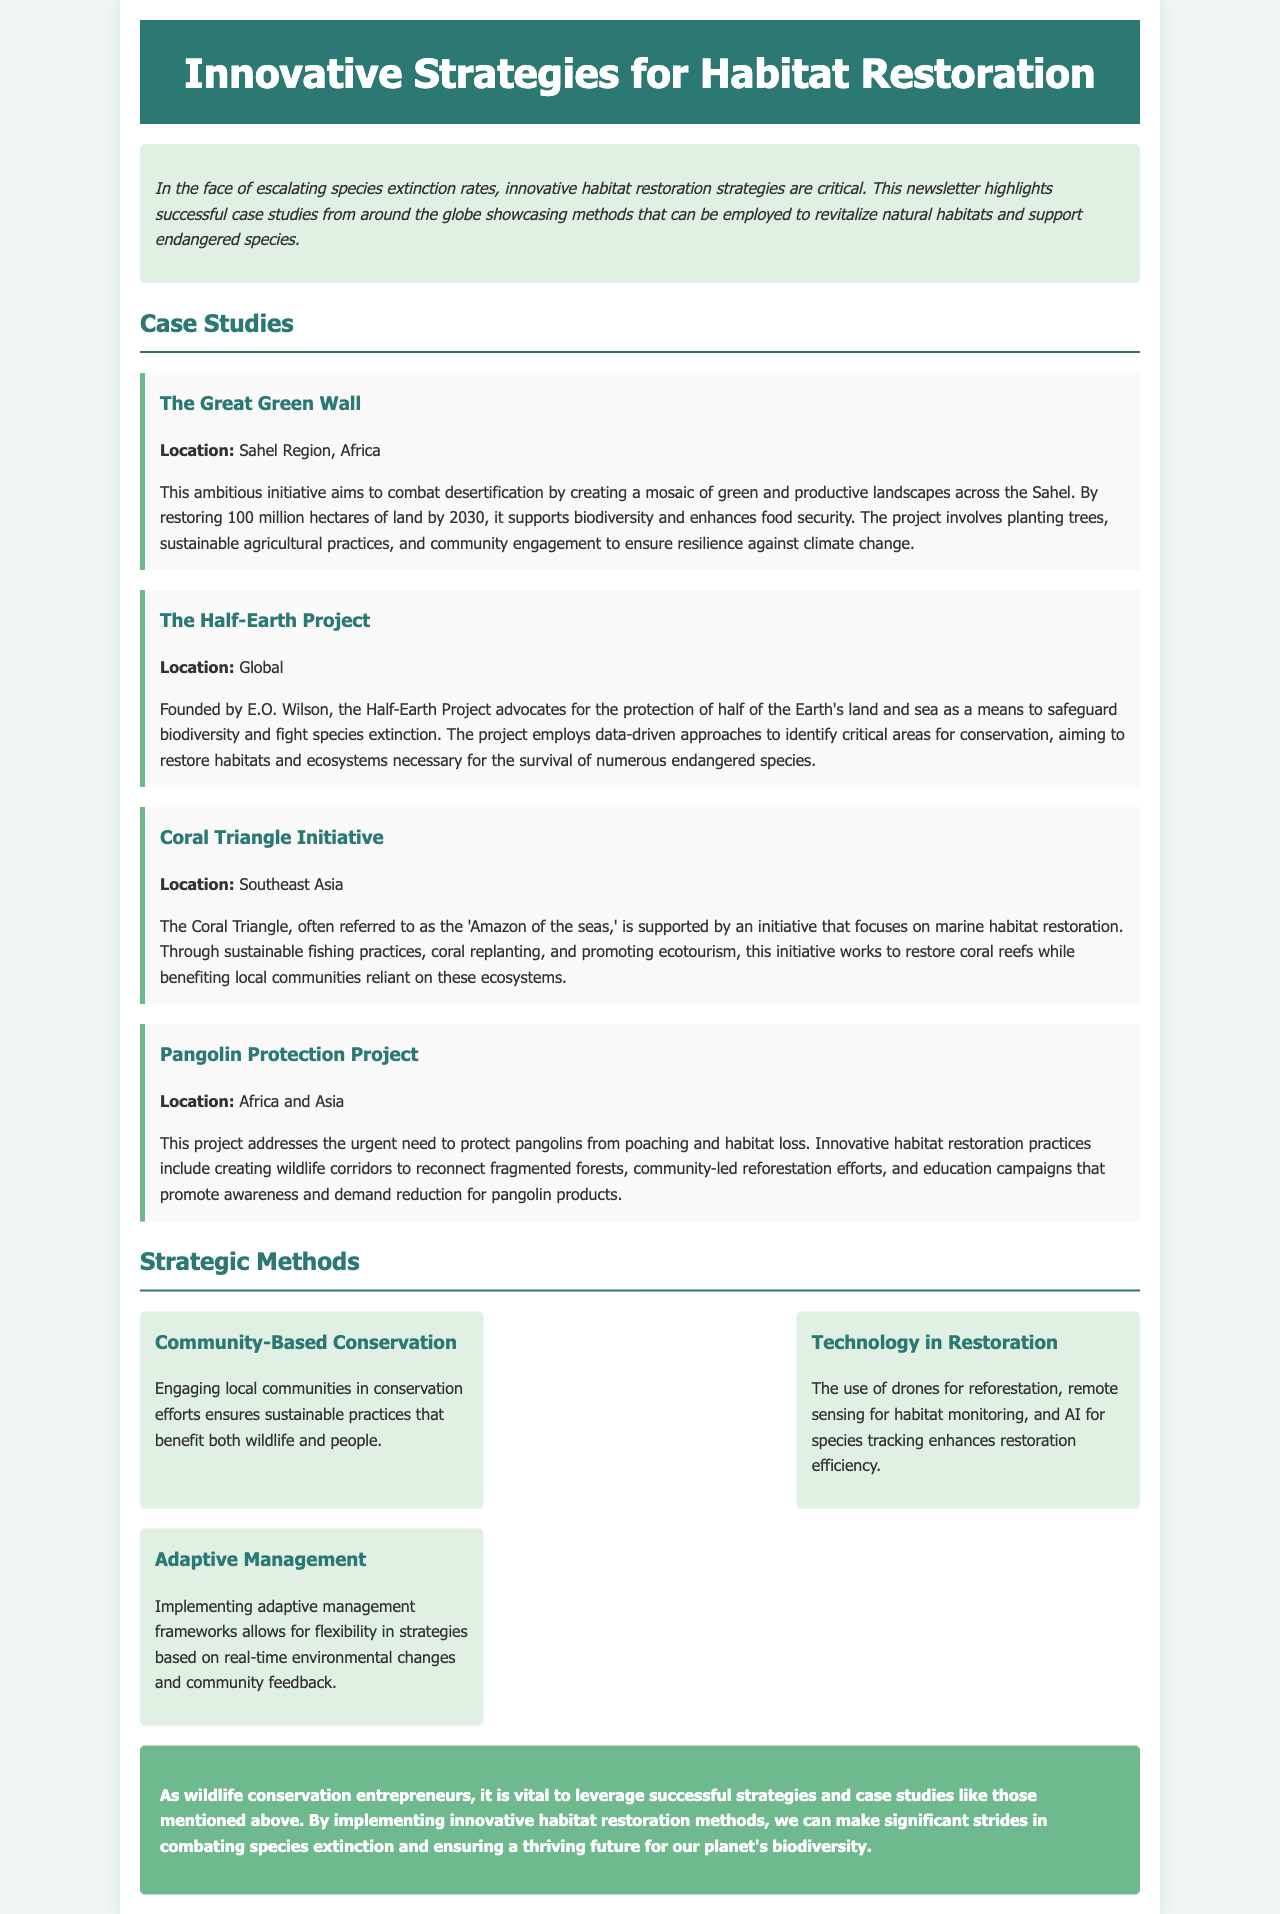what is the title of the newsletter? The title of the newsletter is prominently displayed at the top and is "Innovative Strategies for Habitat Restoration."
Answer: Innovative Strategies for Habitat Restoration where is the Great Green Wall located? The location of the Great Green Wall is specified in the case study section as the Sahel Region, Africa.
Answer: Sahel Region, Africa what is the goal of the Half-Earth Project? The newsletter outlines that the goal of the Half-Earth Project is to protect half of the Earth's land and sea.
Answer: Protect half of the Earth's land and sea how many hectares does the Great Green Wall aim to restore by 2030? The document states that the Great Green Wall aims to restore 100 million hectares of land by 2030.
Answer: 100 million hectares what method enhances restoration efficiency using technology? The newsletter mentions that drones are a technology used for reforestation, helping to enhance restoration efficiency.
Answer: Drones which initiative is referred to as the "Amazon of the seas"? The newsletter refers to the Coral Triangle as the "Amazon of the seas."
Answer: Coral Triangle what is a critical aspect of community-based conservation? The document indicates that community-based conservation engages local communities in conservation efforts.
Answer: Engaging local communities what innovative method is used for species tracking? According to the document, AI is utilized for species tracking in innovative methods.
Answer: AI 